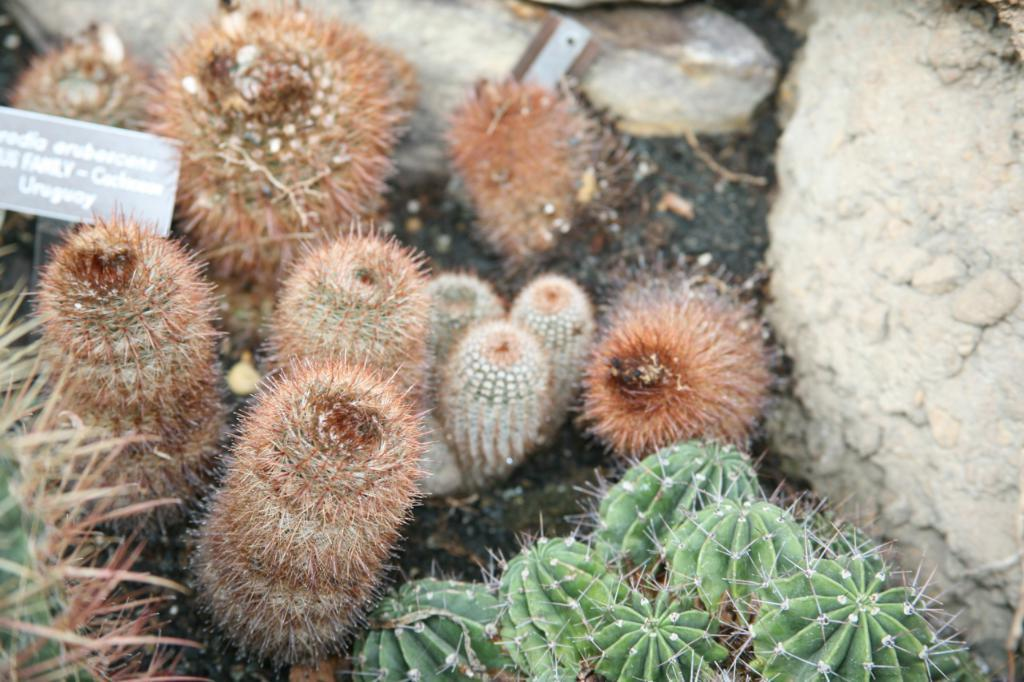What type of plants are in the image? There are cactus plants in the image. What object can be seen in the image besides the plants? There is a board in the image. What is located on the right side of the image? There is a rock on the right side of the image. Reasoning: Let's think step by step by following the given guidelines to produce the conversation. We start by identifying the main subject of the image, which is the cactus plants. Then, we mention the other object present in the image, which is the board. Finally, we describe the location of the rock on the right side of the image. We ensure that each question can be answered definitively with the information given and avoid yes/no questions. Absurd Question/Answer: How many apples are hanging from the cactus plants in the image? There are no apples present in the image; the plants are cacti. What type of sticks can be seen in the image? There are no sticks visible in the image. 